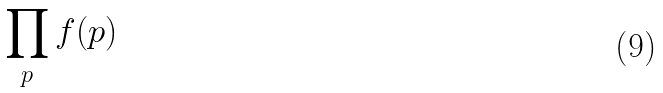<formula> <loc_0><loc_0><loc_500><loc_500>\prod _ { p } f ( p )</formula> 